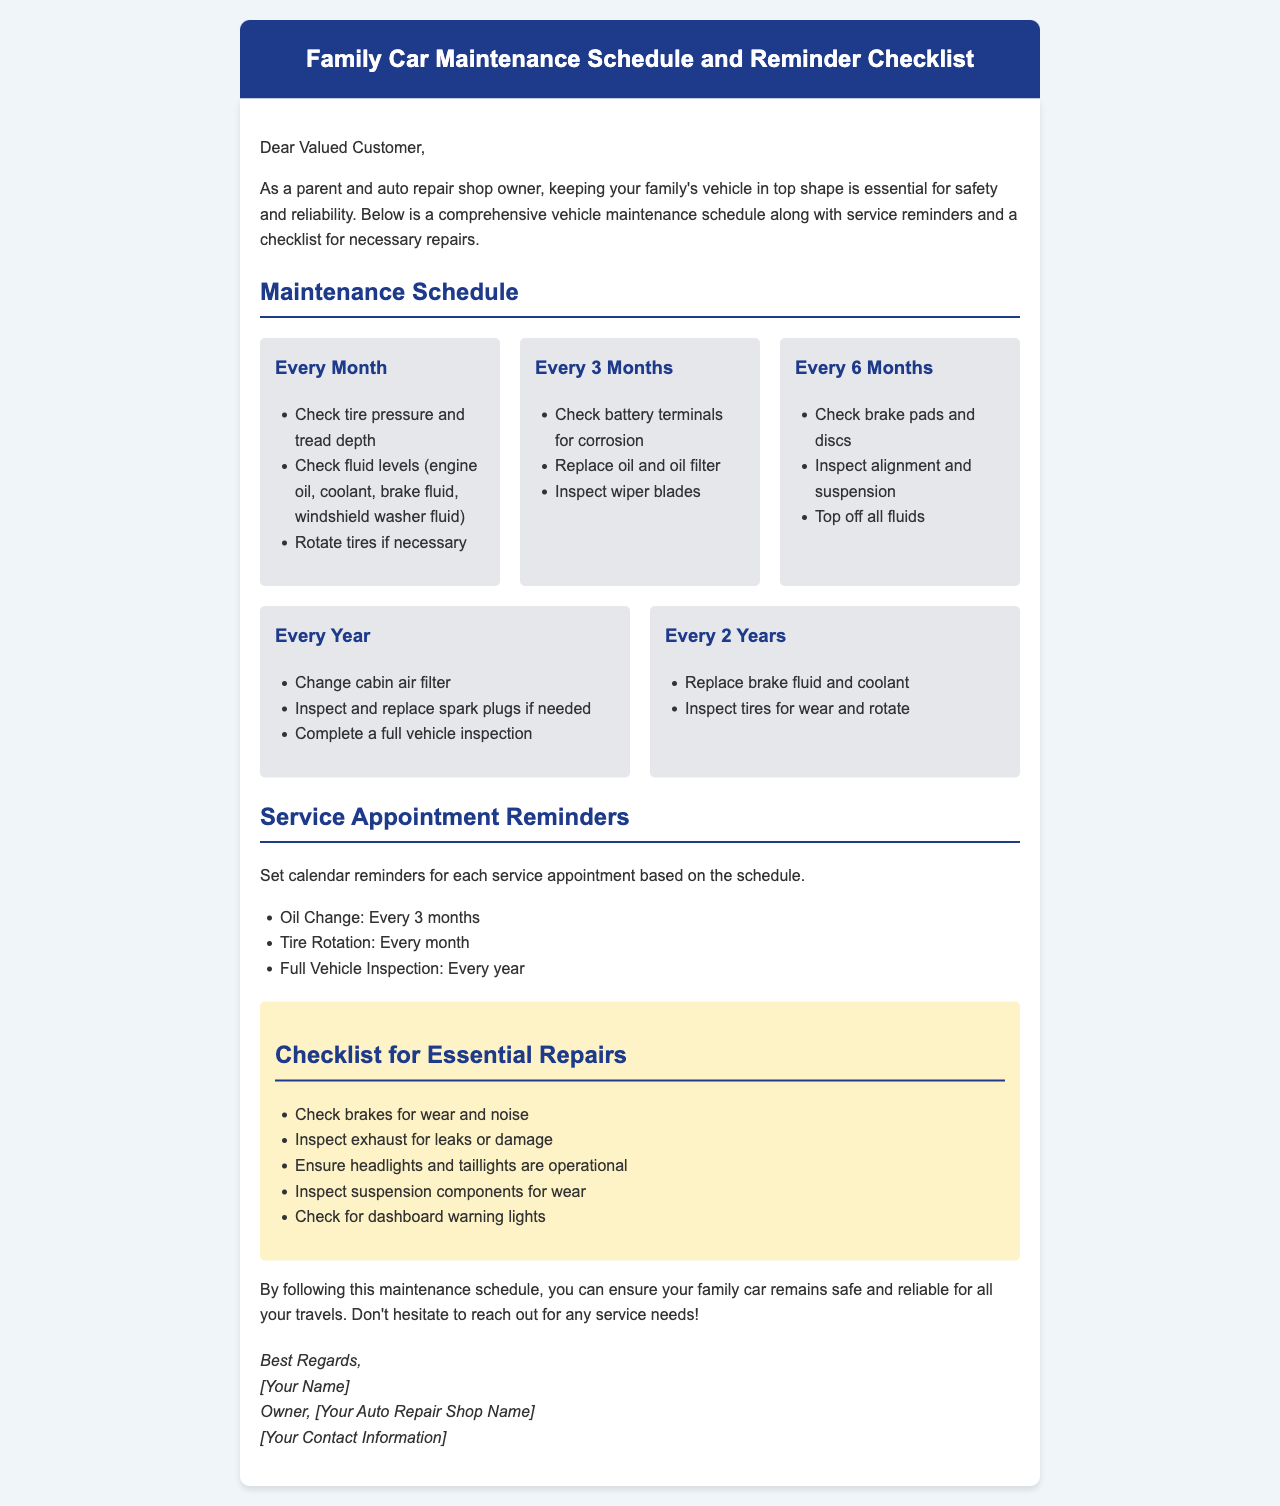What is the title of the document? The title of the document is stated in the header section of the email.
Answer: Family Car Maintenance Schedule and Reminder Checklist How often should you check tire pressure? The maintenance schedule indicates this frequency in the "Every Month" section.
Answer: Every Month What needs to be inspected every 6 months? This information is listed in the "Every 6 Months" section under maintenance tasks.
Answer: Brake pads and discs What should you change every year? The "Every Year" section outlines this requirement for maintenance.
Answer: Cabin air filter How frequently do you need to rotate tires? The schedule specifies this task in the "Every Month" section.
Answer: Every month What is the service appointment reminder for oil change? This reminder is explicitly mentioned in the service appointment reminders list.
Answer: Every 3 months What type of document is this? This question pertains to the overall purpose and format of the content provided.
Answer: Email What is included in the checklist for essential repairs? The checklist specifies components that need checking; it lists several items within the checklist section.
Answer: Brakes for wear and noise How often should a full vehicle inspection be completed? The frequency for this service is detailed in the service appointment reminders section.
Answer: Every year 